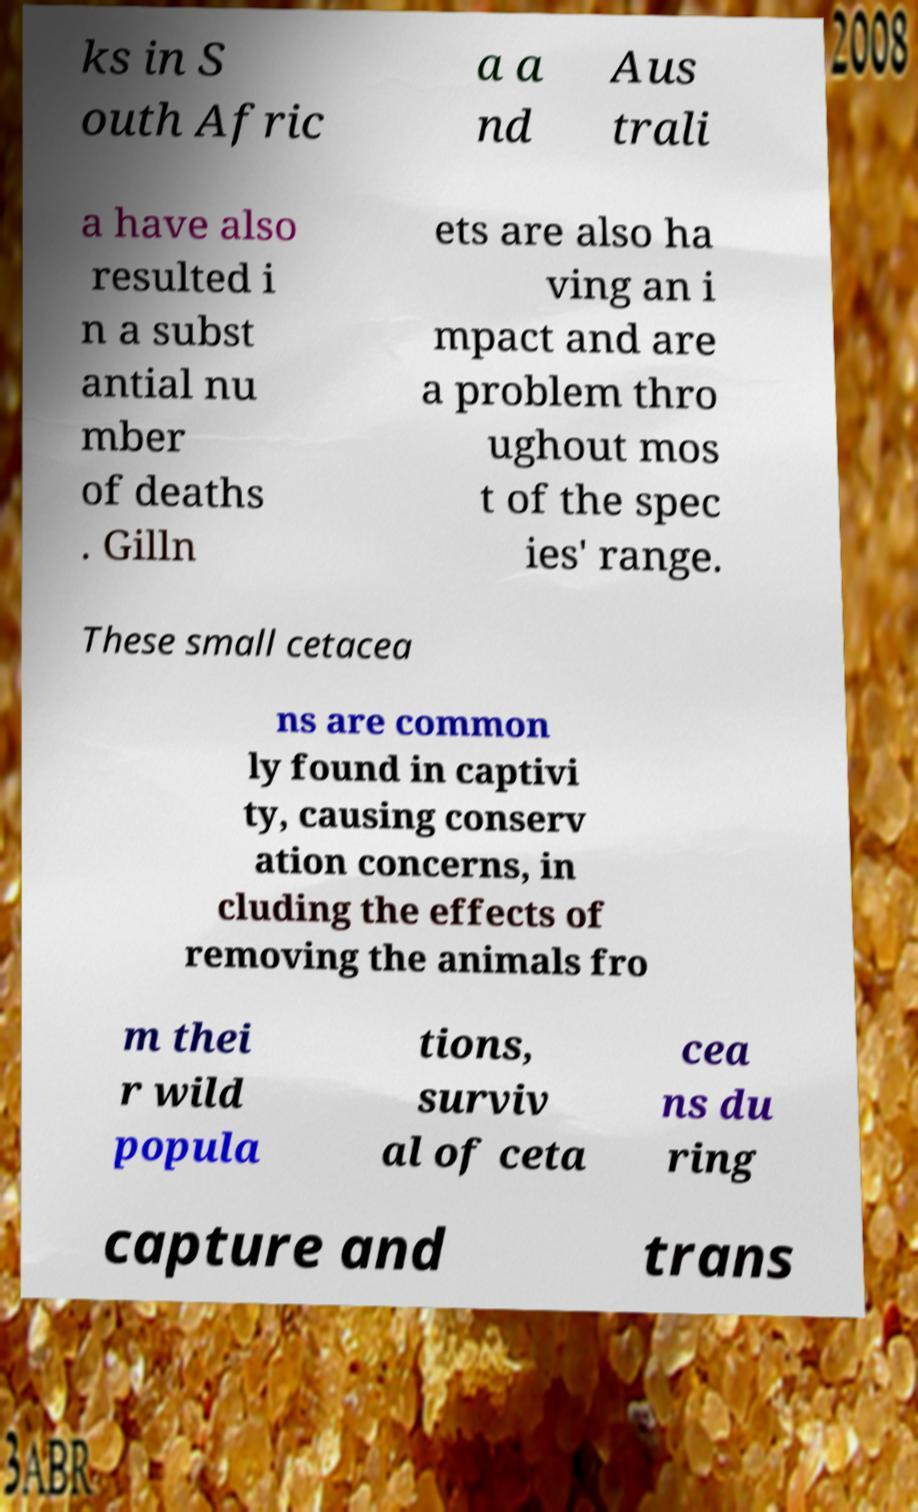Please identify and transcribe the text found in this image. ks in S outh Afric a a nd Aus trali a have also resulted i n a subst antial nu mber of deaths . Gilln ets are also ha ving an i mpact and are a problem thro ughout mos t of the spec ies' range. These small cetacea ns are common ly found in captivi ty, causing conserv ation concerns, in cluding the effects of removing the animals fro m thei r wild popula tions, surviv al of ceta cea ns du ring capture and trans 